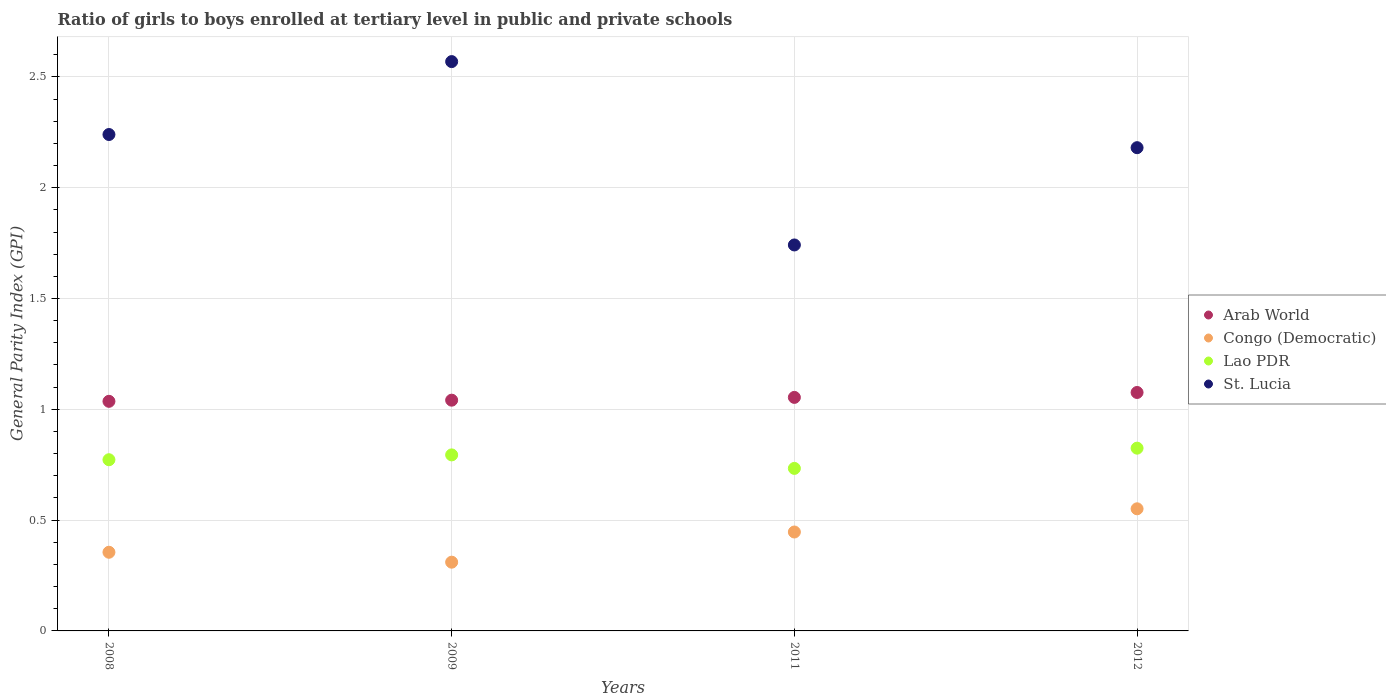What is the general parity index in Congo (Democratic) in 2009?
Offer a terse response. 0.31. Across all years, what is the maximum general parity index in Congo (Democratic)?
Give a very brief answer. 0.55. Across all years, what is the minimum general parity index in Congo (Democratic)?
Ensure brevity in your answer.  0.31. In which year was the general parity index in Lao PDR minimum?
Provide a short and direct response. 2011. What is the total general parity index in St. Lucia in the graph?
Offer a very short reply. 8.73. What is the difference between the general parity index in Congo (Democratic) in 2008 and that in 2011?
Provide a short and direct response. -0.09. What is the difference between the general parity index in Congo (Democratic) in 2008 and the general parity index in Arab World in 2009?
Offer a very short reply. -0.69. What is the average general parity index in Lao PDR per year?
Ensure brevity in your answer.  0.78. In the year 2012, what is the difference between the general parity index in Lao PDR and general parity index in Congo (Democratic)?
Offer a very short reply. 0.27. What is the ratio of the general parity index in Congo (Democratic) in 2011 to that in 2012?
Give a very brief answer. 0.81. Is the general parity index in St. Lucia in 2009 less than that in 2012?
Your answer should be very brief. No. What is the difference between the highest and the second highest general parity index in Arab World?
Ensure brevity in your answer.  0.02. What is the difference between the highest and the lowest general parity index in Lao PDR?
Your answer should be very brief. 0.09. Is the sum of the general parity index in Arab World in 2008 and 2011 greater than the maximum general parity index in St. Lucia across all years?
Your answer should be compact. No. Is it the case that in every year, the sum of the general parity index in Congo (Democratic) and general parity index in Lao PDR  is greater than the sum of general parity index in Arab World and general parity index in St. Lucia?
Your answer should be compact. Yes. Is it the case that in every year, the sum of the general parity index in Arab World and general parity index in St. Lucia  is greater than the general parity index in Lao PDR?
Your response must be concise. Yes. Does the general parity index in Lao PDR monotonically increase over the years?
Provide a succinct answer. No. Is the general parity index in St. Lucia strictly greater than the general parity index in Lao PDR over the years?
Your response must be concise. Yes. Is the general parity index in St. Lucia strictly less than the general parity index in Arab World over the years?
Give a very brief answer. No. How many dotlines are there?
Provide a succinct answer. 4. What is the difference between two consecutive major ticks on the Y-axis?
Ensure brevity in your answer.  0.5. Does the graph contain any zero values?
Keep it short and to the point. No. Where does the legend appear in the graph?
Offer a very short reply. Center right. How many legend labels are there?
Provide a succinct answer. 4. What is the title of the graph?
Provide a succinct answer. Ratio of girls to boys enrolled at tertiary level in public and private schools. Does "Vanuatu" appear as one of the legend labels in the graph?
Provide a short and direct response. No. What is the label or title of the X-axis?
Keep it short and to the point. Years. What is the label or title of the Y-axis?
Your answer should be very brief. General Parity Index (GPI). What is the General Parity Index (GPI) in Arab World in 2008?
Your answer should be compact. 1.04. What is the General Parity Index (GPI) in Congo (Democratic) in 2008?
Ensure brevity in your answer.  0.35. What is the General Parity Index (GPI) of Lao PDR in 2008?
Provide a short and direct response. 0.77. What is the General Parity Index (GPI) in St. Lucia in 2008?
Provide a succinct answer. 2.24. What is the General Parity Index (GPI) of Arab World in 2009?
Offer a terse response. 1.04. What is the General Parity Index (GPI) of Congo (Democratic) in 2009?
Make the answer very short. 0.31. What is the General Parity Index (GPI) in Lao PDR in 2009?
Your response must be concise. 0.79. What is the General Parity Index (GPI) of St. Lucia in 2009?
Offer a very short reply. 2.57. What is the General Parity Index (GPI) in Arab World in 2011?
Give a very brief answer. 1.05. What is the General Parity Index (GPI) of Congo (Democratic) in 2011?
Offer a terse response. 0.45. What is the General Parity Index (GPI) in Lao PDR in 2011?
Keep it short and to the point. 0.73. What is the General Parity Index (GPI) of St. Lucia in 2011?
Make the answer very short. 1.74. What is the General Parity Index (GPI) of Arab World in 2012?
Your response must be concise. 1.08. What is the General Parity Index (GPI) of Congo (Democratic) in 2012?
Your response must be concise. 0.55. What is the General Parity Index (GPI) of Lao PDR in 2012?
Give a very brief answer. 0.82. What is the General Parity Index (GPI) of St. Lucia in 2012?
Your response must be concise. 2.18. Across all years, what is the maximum General Parity Index (GPI) in Arab World?
Offer a terse response. 1.08. Across all years, what is the maximum General Parity Index (GPI) in Congo (Democratic)?
Your answer should be compact. 0.55. Across all years, what is the maximum General Parity Index (GPI) of Lao PDR?
Your answer should be very brief. 0.82. Across all years, what is the maximum General Parity Index (GPI) in St. Lucia?
Provide a succinct answer. 2.57. Across all years, what is the minimum General Parity Index (GPI) of Arab World?
Your answer should be very brief. 1.04. Across all years, what is the minimum General Parity Index (GPI) in Congo (Democratic)?
Your answer should be very brief. 0.31. Across all years, what is the minimum General Parity Index (GPI) of Lao PDR?
Offer a terse response. 0.73. Across all years, what is the minimum General Parity Index (GPI) of St. Lucia?
Offer a very short reply. 1.74. What is the total General Parity Index (GPI) of Arab World in the graph?
Ensure brevity in your answer.  4.21. What is the total General Parity Index (GPI) in Congo (Democratic) in the graph?
Offer a very short reply. 1.66. What is the total General Parity Index (GPI) of Lao PDR in the graph?
Offer a very short reply. 3.12. What is the total General Parity Index (GPI) of St. Lucia in the graph?
Make the answer very short. 8.73. What is the difference between the General Parity Index (GPI) in Arab World in 2008 and that in 2009?
Offer a terse response. -0.01. What is the difference between the General Parity Index (GPI) in Congo (Democratic) in 2008 and that in 2009?
Your answer should be very brief. 0.04. What is the difference between the General Parity Index (GPI) in Lao PDR in 2008 and that in 2009?
Make the answer very short. -0.02. What is the difference between the General Parity Index (GPI) of St. Lucia in 2008 and that in 2009?
Give a very brief answer. -0.33. What is the difference between the General Parity Index (GPI) in Arab World in 2008 and that in 2011?
Make the answer very short. -0.02. What is the difference between the General Parity Index (GPI) in Congo (Democratic) in 2008 and that in 2011?
Your response must be concise. -0.09. What is the difference between the General Parity Index (GPI) in Lao PDR in 2008 and that in 2011?
Make the answer very short. 0.04. What is the difference between the General Parity Index (GPI) of St. Lucia in 2008 and that in 2011?
Give a very brief answer. 0.5. What is the difference between the General Parity Index (GPI) in Arab World in 2008 and that in 2012?
Your answer should be very brief. -0.04. What is the difference between the General Parity Index (GPI) in Congo (Democratic) in 2008 and that in 2012?
Keep it short and to the point. -0.2. What is the difference between the General Parity Index (GPI) of Lao PDR in 2008 and that in 2012?
Provide a short and direct response. -0.05. What is the difference between the General Parity Index (GPI) in St. Lucia in 2008 and that in 2012?
Your answer should be very brief. 0.06. What is the difference between the General Parity Index (GPI) in Arab World in 2009 and that in 2011?
Keep it short and to the point. -0.01. What is the difference between the General Parity Index (GPI) in Congo (Democratic) in 2009 and that in 2011?
Your answer should be very brief. -0.14. What is the difference between the General Parity Index (GPI) of Lao PDR in 2009 and that in 2011?
Provide a succinct answer. 0.06. What is the difference between the General Parity Index (GPI) of St. Lucia in 2009 and that in 2011?
Your answer should be very brief. 0.83. What is the difference between the General Parity Index (GPI) in Arab World in 2009 and that in 2012?
Provide a succinct answer. -0.03. What is the difference between the General Parity Index (GPI) of Congo (Democratic) in 2009 and that in 2012?
Provide a short and direct response. -0.24. What is the difference between the General Parity Index (GPI) of Lao PDR in 2009 and that in 2012?
Make the answer very short. -0.03. What is the difference between the General Parity Index (GPI) of St. Lucia in 2009 and that in 2012?
Your response must be concise. 0.39. What is the difference between the General Parity Index (GPI) of Arab World in 2011 and that in 2012?
Your answer should be compact. -0.02. What is the difference between the General Parity Index (GPI) in Congo (Democratic) in 2011 and that in 2012?
Keep it short and to the point. -0.1. What is the difference between the General Parity Index (GPI) in Lao PDR in 2011 and that in 2012?
Ensure brevity in your answer.  -0.09. What is the difference between the General Parity Index (GPI) in St. Lucia in 2011 and that in 2012?
Keep it short and to the point. -0.44. What is the difference between the General Parity Index (GPI) of Arab World in 2008 and the General Parity Index (GPI) of Congo (Democratic) in 2009?
Offer a terse response. 0.73. What is the difference between the General Parity Index (GPI) of Arab World in 2008 and the General Parity Index (GPI) of Lao PDR in 2009?
Give a very brief answer. 0.24. What is the difference between the General Parity Index (GPI) of Arab World in 2008 and the General Parity Index (GPI) of St. Lucia in 2009?
Keep it short and to the point. -1.53. What is the difference between the General Parity Index (GPI) in Congo (Democratic) in 2008 and the General Parity Index (GPI) in Lao PDR in 2009?
Keep it short and to the point. -0.44. What is the difference between the General Parity Index (GPI) of Congo (Democratic) in 2008 and the General Parity Index (GPI) of St. Lucia in 2009?
Keep it short and to the point. -2.21. What is the difference between the General Parity Index (GPI) of Lao PDR in 2008 and the General Parity Index (GPI) of St. Lucia in 2009?
Ensure brevity in your answer.  -1.8. What is the difference between the General Parity Index (GPI) of Arab World in 2008 and the General Parity Index (GPI) of Congo (Democratic) in 2011?
Your response must be concise. 0.59. What is the difference between the General Parity Index (GPI) of Arab World in 2008 and the General Parity Index (GPI) of Lao PDR in 2011?
Keep it short and to the point. 0.3. What is the difference between the General Parity Index (GPI) in Arab World in 2008 and the General Parity Index (GPI) in St. Lucia in 2011?
Your answer should be very brief. -0.71. What is the difference between the General Parity Index (GPI) in Congo (Democratic) in 2008 and the General Parity Index (GPI) in Lao PDR in 2011?
Your answer should be very brief. -0.38. What is the difference between the General Parity Index (GPI) of Congo (Democratic) in 2008 and the General Parity Index (GPI) of St. Lucia in 2011?
Provide a short and direct response. -1.39. What is the difference between the General Parity Index (GPI) in Lao PDR in 2008 and the General Parity Index (GPI) in St. Lucia in 2011?
Ensure brevity in your answer.  -0.97. What is the difference between the General Parity Index (GPI) in Arab World in 2008 and the General Parity Index (GPI) in Congo (Democratic) in 2012?
Your answer should be compact. 0.48. What is the difference between the General Parity Index (GPI) in Arab World in 2008 and the General Parity Index (GPI) in Lao PDR in 2012?
Offer a very short reply. 0.21. What is the difference between the General Parity Index (GPI) in Arab World in 2008 and the General Parity Index (GPI) in St. Lucia in 2012?
Ensure brevity in your answer.  -1.14. What is the difference between the General Parity Index (GPI) of Congo (Democratic) in 2008 and the General Parity Index (GPI) of Lao PDR in 2012?
Your response must be concise. -0.47. What is the difference between the General Parity Index (GPI) of Congo (Democratic) in 2008 and the General Parity Index (GPI) of St. Lucia in 2012?
Your response must be concise. -1.83. What is the difference between the General Parity Index (GPI) of Lao PDR in 2008 and the General Parity Index (GPI) of St. Lucia in 2012?
Your answer should be compact. -1.41. What is the difference between the General Parity Index (GPI) in Arab World in 2009 and the General Parity Index (GPI) in Congo (Democratic) in 2011?
Ensure brevity in your answer.  0.59. What is the difference between the General Parity Index (GPI) of Arab World in 2009 and the General Parity Index (GPI) of Lao PDR in 2011?
Your response must be concise. 0.31. What is the difference between the General Parity Index (GPI) in Arab World in 2009 and the General Parity Index (GPI) in St. Lucia in 2011?
Your response must be concise. -0.7. What is the difference between the General Parity Index (GPI) in Congo (Democratic) in 2009 and the General Parity Index (GPI) in Lao PDR in 2011?
Make the answer very short. -0.42. What is the difference between the General Parity Index (GPI) in Congo (Democratic) in 2009 and the General Parity Index (GPI) in St. Lucia in 2011?
Ensure brevity in your answer.  -1.43. What is the difference between the General Parity Index (GPI) in Lao PDR in 2009 and the General Parity Index (GPI) in St. Lucia in 2011?
Provide a succinct answer. -0.95. What is the difference between the General Parity Index (GPI) of Arab World in 2009 and the General Parity Index (GPI) of Congo (Democratic) in 2012?
Offer a very short reply. 0.49. What is the difference between the General Parity Index (GPI) in Arab World in 2009 and the General Parity Index (GPI) in Lao PDR in 2012?
Give a very brief answer. 0.22. What is the difference between the General Parity Index (GPI) in Arab World in 2009 and the General Parity Index (GPI) in St. Lucia in 2012?
Make the answer very short. -1.14. What is the difference between the General Parity Index (GPI) of Congo (Democratic) in 2009 and the General Parity Index (GPI) of Lao PDR in 2012?
Your answer should be compact. -0.51. What is the difference between the General Parity Index (GPI) of Congo (Democratic) in 2009 and the General Parity Index (GPI) of St. Lucia in 2012?
Your answer should be compact. -1.87. What is the difference between the General Parity Index (GPI) of Lao PDR in 2009 and the General Parity Index (GPI) of St. Lucia in 2012?
Offer a very short reply. -1.39. What is the difference between the General Parity Index (GPI) of Arab World in 2011 and the General Parity Index (GPI) of Congo (Democratic) in 2012?
Your response must be concise. 0.5. What is the difference between the General Parity Index (GPI) of Arab World in 2011 and the General Parity Index (GPI) of Lao PDR in 2012?
Provide a succinct answer. 0.23. What is the difference between the General Parity Index (GPI) of Arab World in 2011 and the General Parity Index (GPI) of St. Lucia in 2012?
Ensure brevity in your answer.  -1.13. What is the difference between the General Parity Index (GPI) in Congo (Democratic) in 2011 and the General Parity Index (GPI) in Lao PDR in 2012?
Give a very brief answer. -0.38. What is the difference between the General Parity Index (GPI) in Congo (Democratic) in 2011 and the General Parity Index (GPI) in St. Lucia in 2012?
Offer a very short reply. -1.73. What is the difference between the General Parity Index (GPI) in Lao PDR in 2011 and the General Parity Index (GPI) in St. Lucia in 2012?
Keep it short and to the point. -1.45. What is the average General Parity Index (GPI) of Arab World per year?
Offer a very short reply. 1.05. What is the average General Parity Index (GPI) in Congo (Democratic) per year?
Your response must be concise. 0.42. What is the average General Parity Index (GPI) of Lao PDR per year?
Offer a very short reply. 0.78. What is the average General Parity Index (GPI) of St. Lucia per year?
Offer a very short reply. 2.18. In the year 2008, what is the difference between the General Parity Index (GPI) in Arab World and General Parity Index (GPI) in Congo (Democratic)?
Offer a terse response. 0.68. In the year 2008, what is the difference between the General Parity Index (GPI) in Arab World and General Parity Index (GPI) in Lao PDR?
Your response must be concise. 0.26. In the year 2008, what is the difference between the General Parity Index (GPI) of Arab World and General Parity Index (GPI) of St. Lucia?
Give a very brief answer. -1.2. In the year 2008, what is the difference between the General Parity Index (GPI) in Congo (Democratic) and General Parity Index (GPI) in Lao PDR?
Keep it short and to the point. -0.42. In the year 2008, what is the difference between the General Parity Index (GPI) in Congo (Democratic) and General Parity Index (GPI) in St. Lucia?
Offer a very short reply. -1.89. In the year 2008, what is the difference between the General Parity Index (GPI) in Lao PDR and General Parity Index (GPI) in St. Lucia?
Give a very brief answer. -1.47. In the year 2009, what is the difference between the General Parity Index (GPI) in Arab World and General Parity Index (GPI) in Congo (Democratic)?
Your answer should be very brief. 0.73. In the year 2009, what is the difference between the General Parity Index (GPI) in Arab World and General Parity Index (GPI) in Lao PDR?
Keep it short and to the point. 0.25. In the year 2009, what is the difference between the General Parity Index (GPI) of Arab World and General Parity Index (GPI) of St. Lucia?
Provide a succinct answer. -1.53. In the year 2009, what is the difference between the General Parity Index (GPI) of Congo (Democratic) and General Parity Index (GPI) of Lao PDR?
Offer a very short reply. -0.48. In the year 2009, what is the difference between the General Parity Index (GPI) of Congo (Democratic) and General Parity Index (GPI) of St. Lucia?
Keep it short and to the point. -2.26. In the year 2009, what is the difference between the General Parity Index (GPI) in Lao PDR and General Parity Index (GPI) in St. Lucia?
Your answer should be compact. -1.77. In the year 2011, what is the difference between the General Parity Index (GPI) in Arab World and General Parity Index (GPI) in Congo (Democratic)?
Give a very brief answer. 0.61. In the year 2011, what is the difference between the General Parity Index (GPI) of Arab World and General Parity Index (GPI) of Lao PDR?
Ensure brevity in your answer.  0.32. In the year 2011, what is the difference between the General Parity Index (GPI) in Arab World and General Parity Index (GPI) in St. Lucia?
Provide a short and direct response. -0.69. In the year 2011, what is the difference between the General Parity Index (GPI) of Congo (Democratic) and General Parity Index (GPI) of Lao PDR?
Give a very brief answer. -0.29. In the year 2011, what is the difference between the General Parity Index (GPI) in Congo (Democratic) and General Parity Index (GPI) in St. Lucia?
Ensure brevity in your answer.  -1.3. In the year 2011, what is the difference between the General Parity Index (GPI) in Lao PDR and General Parity Index (GPI) in St. Lucia?
Provide a short and direct response. -1.01. In the year 2012, what is the difference between the General Parity Index (GPI) in Arab World and General Parity Index (GPI) in Congo (Democratic)?
Keep it short and to the point. 0.52. In the year 2012, what is the difference between the General Parity Index (GPI) in Arab World and General Parity Index (GPI) in Lao PDR?
Offer a terse response. 0.25. In the year 2012, what is the difference between the General Parity Index (GPI) of Arab World and General Parity Index (GPI) of St. Lucia?
Keep it short and to the point. -1.1. In the year 2012, what is the difference between the General Parity Index (GPI) in Congo (Democratic) and General Parity Index (GPI) in Lao PDR?
Your answer should be compact. -0.27. In the year 2012, what is the difference between the General Parity Index (GPI) of Congo (Democratic) and General Parity Index (GPI) of St. Lucia?
Provide a succinct answer. -1.63. In the year 2012, what is the difference between the General Parity Index (GPI) of Lao PDR and General Parity Index (GPI) of St. Lucia?
Your response must be concise. -1.36. What is the ratio of the General Parity Index (GPI) of Congo (Democratic) in 2008 to that in 2009?
Your answer should be very brief. 1.14. What is the ratio of the General Parity Index (GPI) of Lao PDR in 2008 to that in 2009?
Keep it short and to the point. 0.97. What is the ratio of the General Parity Index (GPI) of St. Lucia in 2008 to that in 2009?
Your answer should be very brief. 0.87. What is the ratio of the General Parity Index (GPI) of Arab World in 2008 to that in 2011?
Make the answer very short. 0.98. What is the ratio of the General Parity Index (GPI) of Congo (Democratic) in 2008 to that in 2011?
Offer a terse response. 0.8. What is the ratio of the General Parity Index (GPI) of Lao PDR in 2008 to that in 2011?
Your answer should be very brief. 1.05. What is the ratio of the General Parity Index (GPI) in St. Lucia in 2008 to that in 2011?
Ensure brevity in your answer.  1.29. What is the ratio of the General Parity Index (GPI) of Arab World in 2008 to that in 2012?
Ensure brevity in your answer.  0.96. What is the ratio of the General Parity Index (GPI) in Congo (Democratic) in 2008 to that in 2012?
Offer a very short reply. 0.64. What is the ratio of the General Parity Index (GPI) in Lao PDR in 2008 to that in 2012?
Provide a succinct answer. 0.94. What is the ratio of the General Parity Index (GPI) in St. Lucia in 2008 to that in 2012?
Provide a succinct answer. 1.03. What is the ratio of the General Parity Index (GPI) of Congo (Democratic) in 2009 to that in 2011?
Keep it short and to the point. 0.69. What is the ratio of the General Parity Index (GPI) of Lao PDR in 2009 to that in 2011?
Your answer should be very brief. 1.08. What is the ratio of the General Parity Index (GPI) in St. Lucia in 2009 to that in 2011?
Offer a very short reply. 1.48. What is the ratio of the General Parity Index (GPI) in Arab World in 2009 to that in 2012?
Keep it short and to the point. 0.97. What is the ratio of the General Parity Index (GPI) of Congo (Democratic) in 2009 to that in 2012?
Your answer should be compact. 0.56. What is the ratio of the General Parity Index (GPI) in Lao PDR in 2009 to that in 2012?
Offer a very short reply. 0.96. What is the ratio of the General Parity Index (GPI) in St. Lucia in 2009 to that in 2012?
Offer a terse response. 1.18. What is the ratio of the General Parity Index (GPI) in Arab World in 2011 to that in 2012?
Provide a succinct answer. 0.98. What is the ratio of the General Parity Index (GPI) in Congo (Democratic) in 2011 to that in 2012?
Make the answer very short. 0.81. What is the ratio of the General Parity Index (GPI) in Lao PDR in 2011 to that in 2012?
Offer a very short reply. 0.89. What is the ratio of the General Parity Index (GPI) in St. Lucia in 2011 to that in 2012?
Provide a succinct answer. 0.8. What is the difference between the highest and the second highest General Parity Index (GPI) in Arab World?
Offer a terse response. 0.02. What is the difference between the highest and the second highest General Parity Index (GPI) in Congo (Democratic)?
Ensure brevity in your answer.  0.1. What is the difference between the highest and the second highest General Parity Index (GPI) in Lao PDR?
Your response must be concise. 0.03. What is the difference between the highest and the second highest General Parity Index (GPI) of St. Lucia?
Your response must be concise. 0.33. What is the difference between the highest and the lowest General Parity Index (GPI) of Arab World?
Provide a short and direct response. 0.04. What is the difference between the highest and the lowest General Parity Index (GPI) in Congo (Democratic)?
Your response must be concise. 0.24. What is the difference between the highest and the lowest General Parity Index (GPI) in Lao PDR?
Give a very brief answer. 0.09. What is the difference between the highest and the lowest General Parity Index (GPI) of St. Lucia?
Provide a succinct answer. 0.83. 